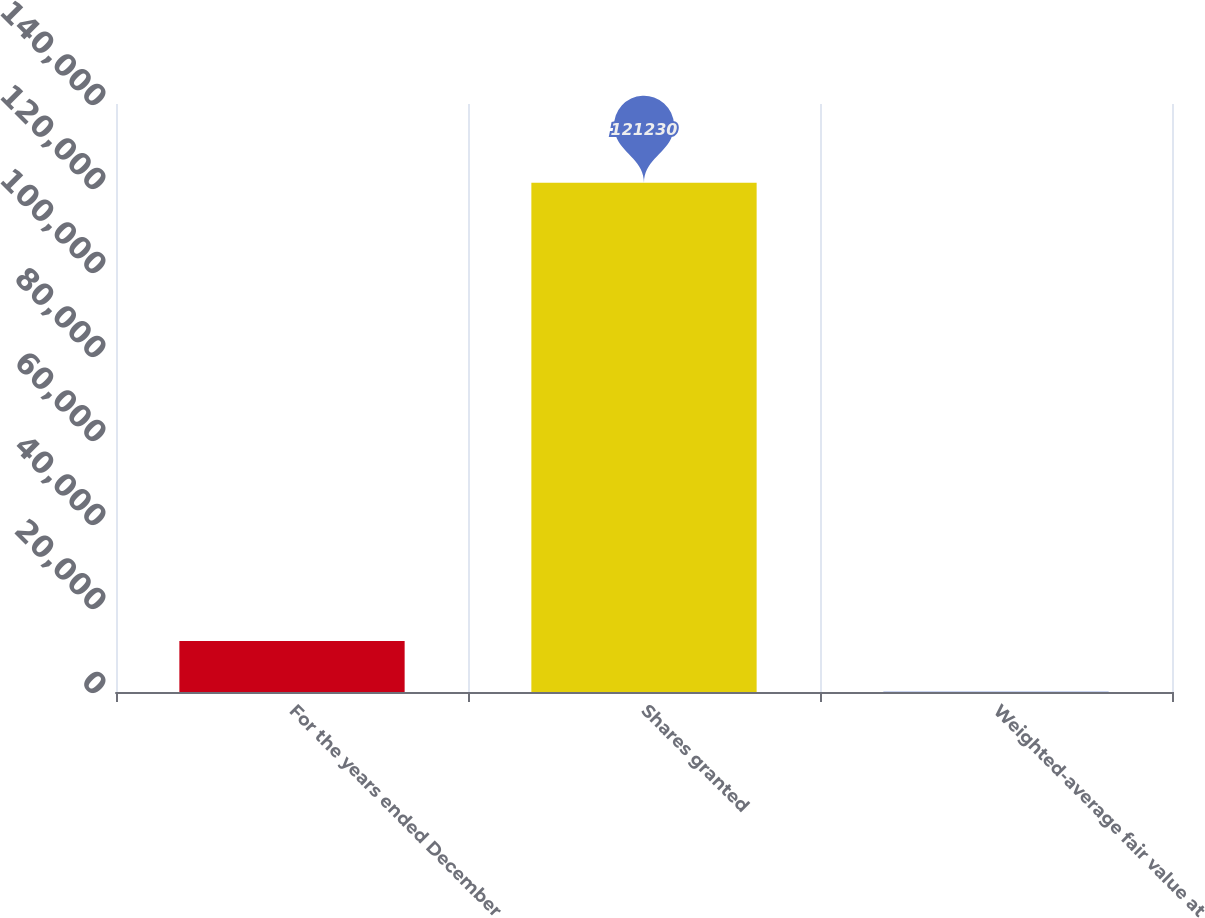Convert chart to OTSL. <chart><loc_0><loc_0><loc_500><loc_500><bar_chart><fcel>For the years ended December<fcel>Shares granted<fcel>Weighted-average fair value at<nl><fcel>12153.1<fcel>121230<fcel>33.4<nl></chart> 